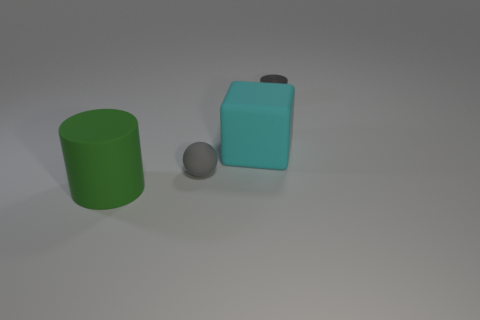Is there any other thing that has the same material as the small gray cylinder?
Give a very brief answer. No. There is a small thing that is behind the large matte thing that is to the right of the cylinder on the left side of the tiny gray metallic cylinder; what is its color?
Offer a very short reply. Gray. Are the tiny gray ball and the cylinder behind the large matte cylinder made of the same material?
Your response must be concise. No. What is the material of the ball?
Offer a very short reply. Rubber. There is another tiny thing that is the same color as the small shiny thing; what is its material?
Provide a short and direct response. Rubber. How many other objects are there of the same material as the small ball?
Offer a terse response. 2. There is a rubber object that is left of the large cyan cube and behind the big cylinder; what shape is it?
Keep it short and to the point. Sphere. There is another large thing that is made of the same material as the green thing; what is its color?
Offer a terse response. Cyan. Is the number of small metallic objects behind the cyan rubber object the same as the number of things?
Your answer should be compact. No. The gray matte object that is the same size as the metallic cylinder is what shape?
Provide a succinct answer. Sphere. 